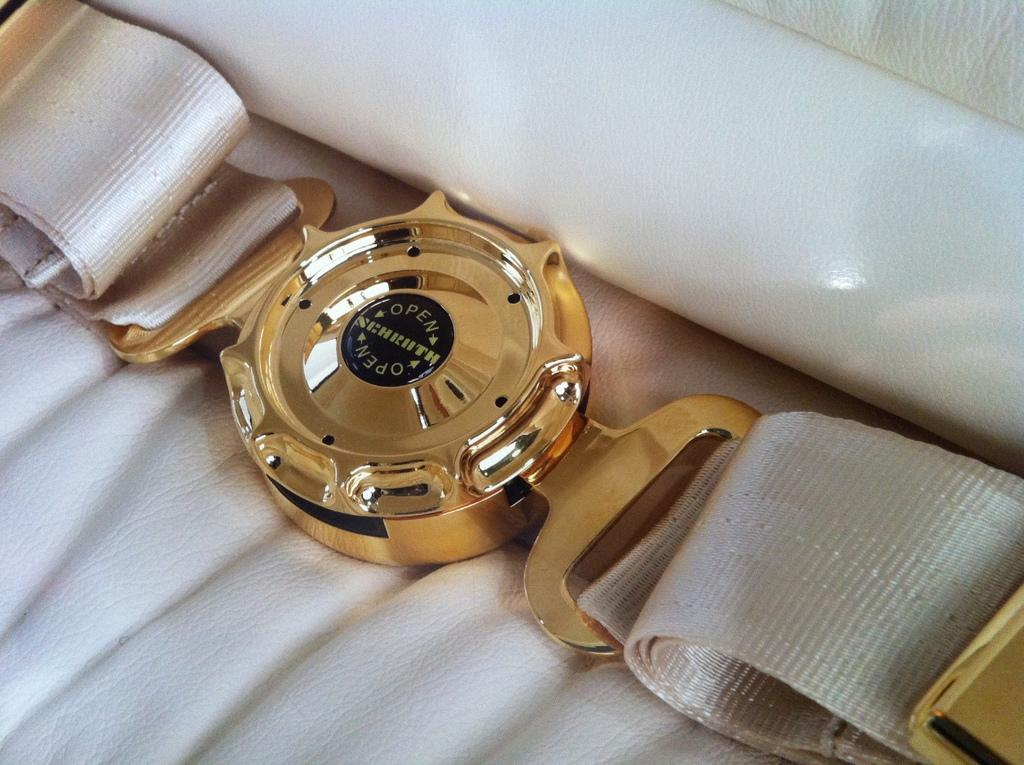<image>
Render a clear and concise summary of the photo. A gold watch streched out on a white cloth and the watch has the word open on it. 